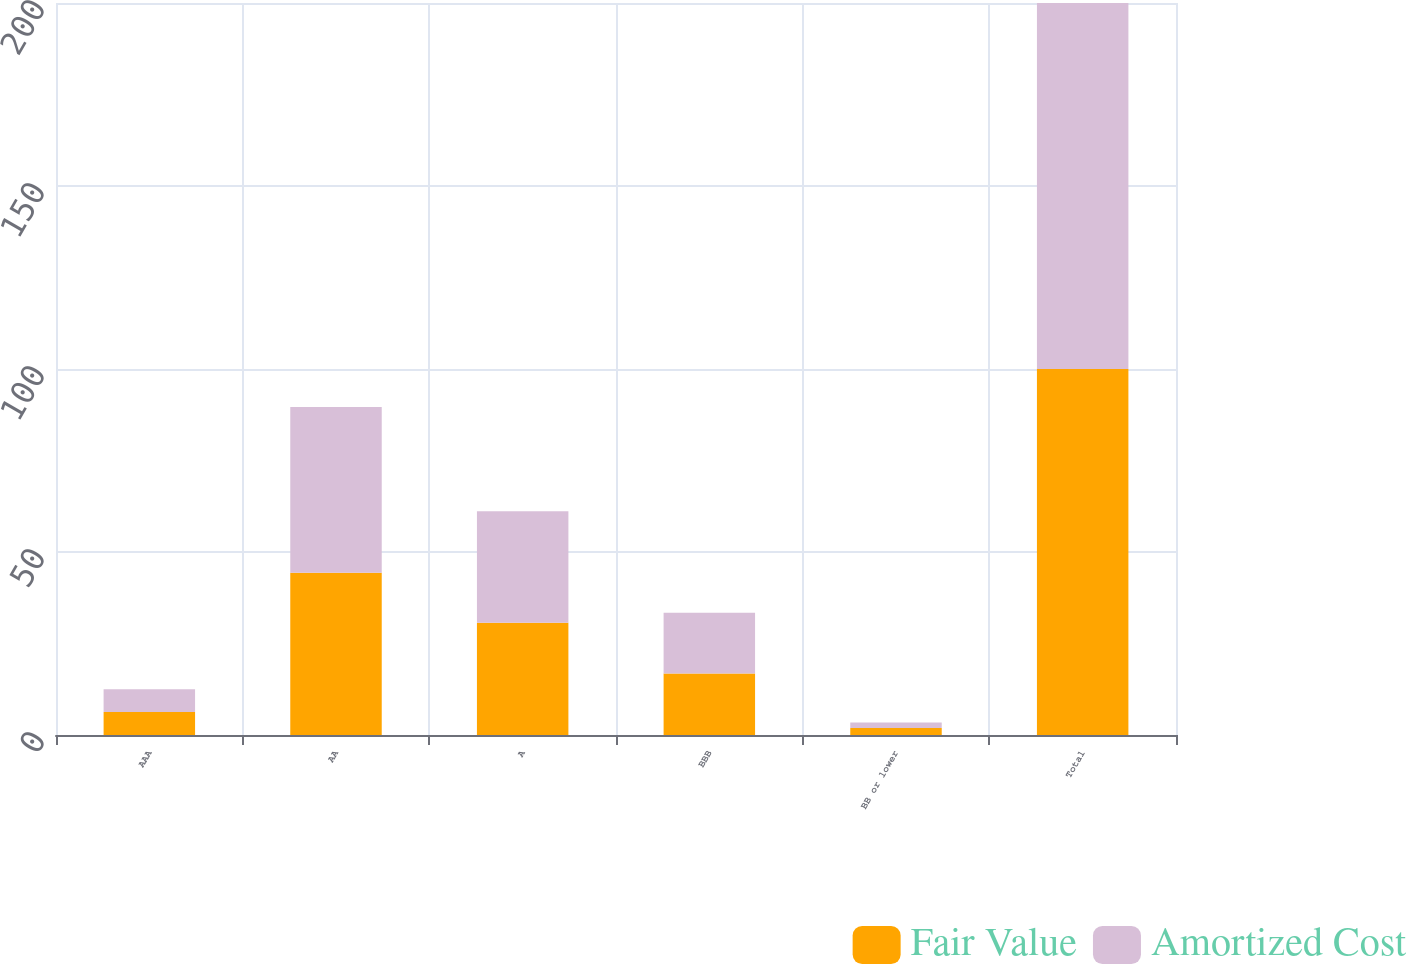<chart> <loc_0><loc_0><loc_500><loc_500><stacked_bar_chart><ecel><fcel>AAA<fcel>AA<fcel>A<fcel>BBB<fcel>BB or lower<fcel>Total<nl><fcel>Fair Value<fcel>6.3<fcel>44.3<fcel>30.7<fcel>16.8<fcel>1.9<fcel>100<nl><fcel>Amortized Cost<fcel>6.2<fcel>45.3<fcel>30.4<fcel>16.6<fcel>1.5<fcel>100<nl></chart> 